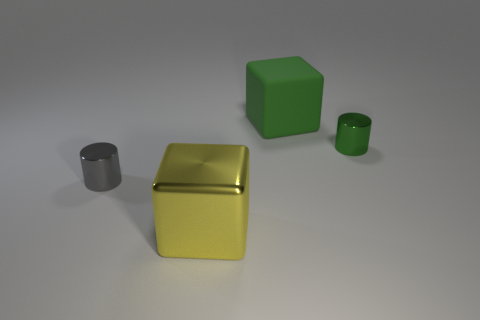Add 3 green metal objects. How many objects exist? 7 Subtract 1 gray cylinders. How many objects are left? 3 Subtract all gray cylinders. Subtract all brown matte spheres. How many objects are left? 3 Add 1 gray things. How many gray things are left? 2 Add 1 green matte cubes. How many green matte cubes exist? 2 